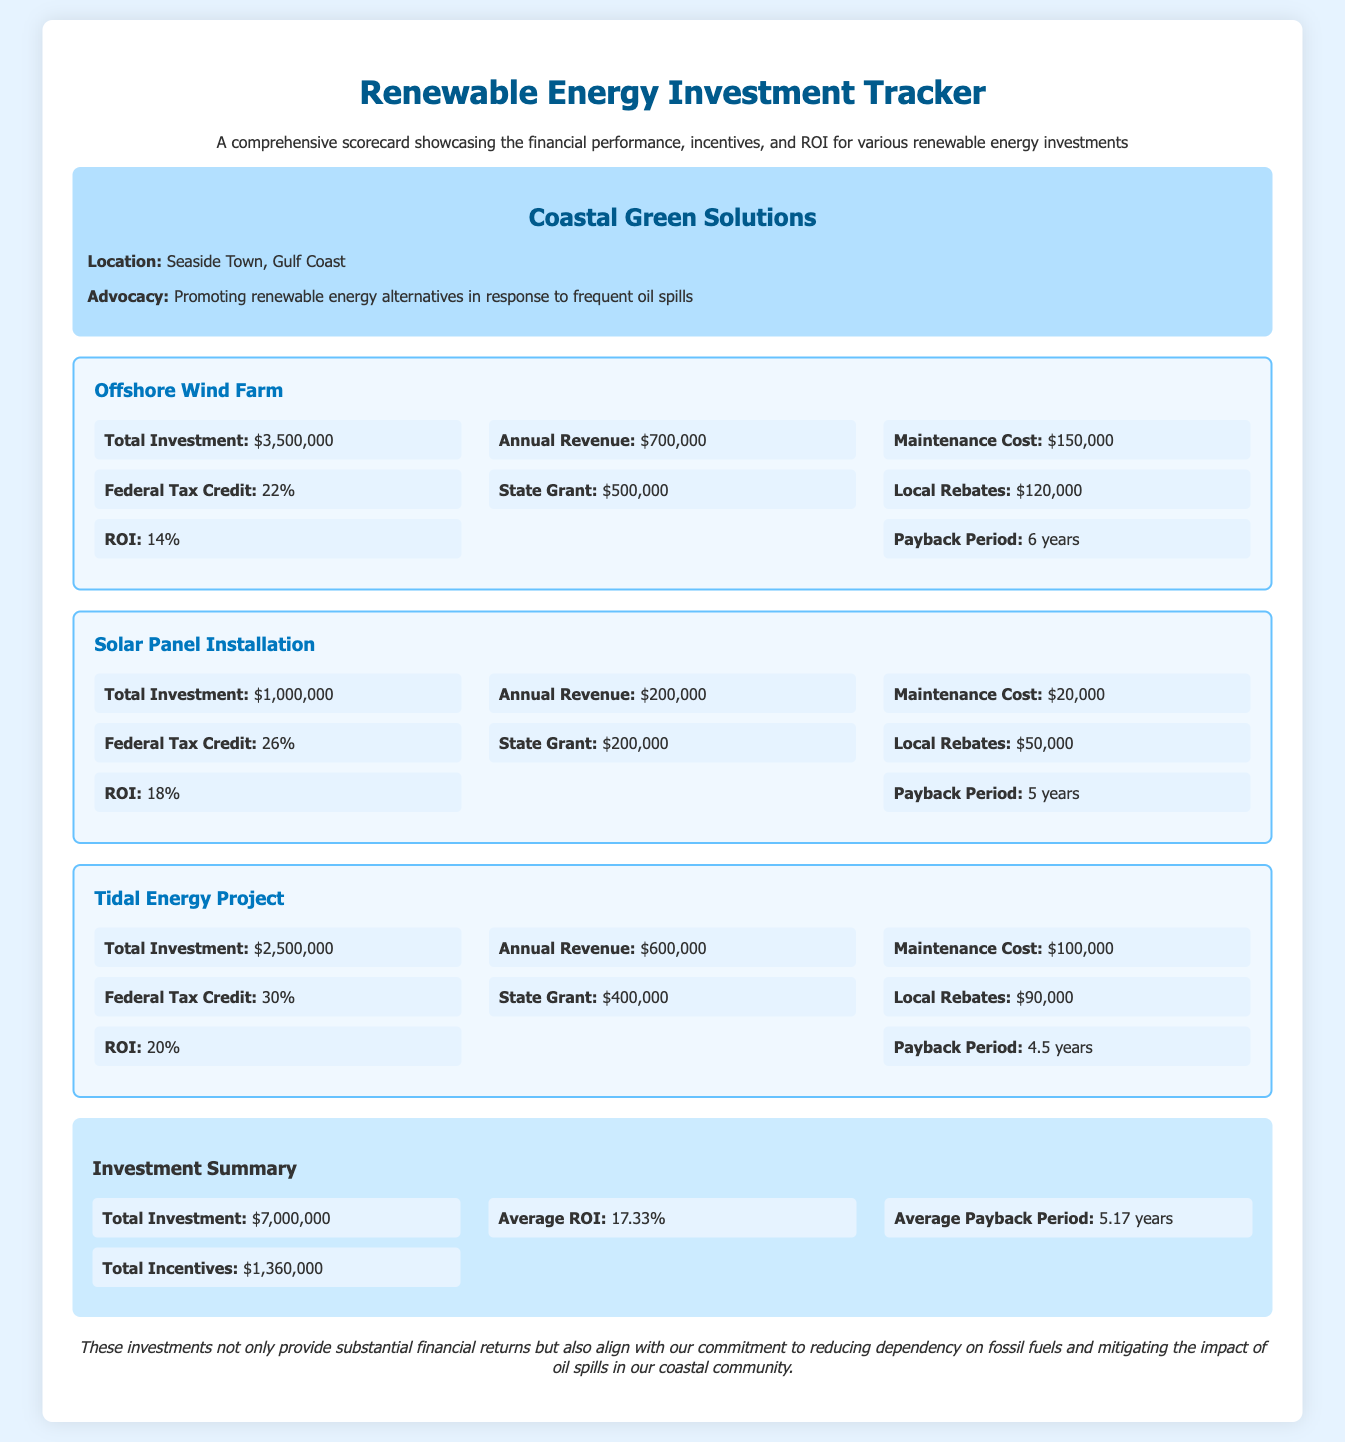what is the total investment for the Offshore Wind Farm? The total investment for the Offshore Wind Farm is stated in the metrics section as $3,500,000.
Answer: $3,500,000 what is the ROI for the Solar Panel Installation? The ROI for the Solar Panel Installation is provided in the metrics section as 18%.
Answer: 18% how much is the federal tax credit for the Tidal Energy Project? The federal tax credit for the Tidal Energy Project is indicated as 30% in the metrics section.
Answer: 30% what is the average payback period for all investments? The average payback period is calculated in the summary section and indicated as 5.17 years.
Answer: 5.17 years what is the total amount of local rebates available? The total amount of local rebates is the sum of local rebates from all projects, which are $120,000 + $50,000 + $90,000 = $260,000.
Answer: $260,000 which investment has the highest maintenance cost? The investment with the highest maintenance cost is mentioned for the Offshore Wind Farm, with a maintenance cost of $150,000.
Answer: $150,000 how many years is the payback period for the Tidal Energy Project? The payback period for the Tidal Energy Project is stated in the metrics section as 4.5 years.
Answer: 4.5 years what is the total amount of federal tax credits provided across all projects? The total federal tax credits are $770,000, calculated as $770,000 = $770,000 (22% for Offshore Wind + 26% for Solar + 30% for Tidal Energy).
Answer: $770,000 what advocacy is Coastal Green Solutions focused on? The advocacy focus of Coastal Green Solutions is promoting renewable energy alternatives in response to frequent oil spills.
Answer: promoting renewable energy alternatives in response to frequent oil spills 